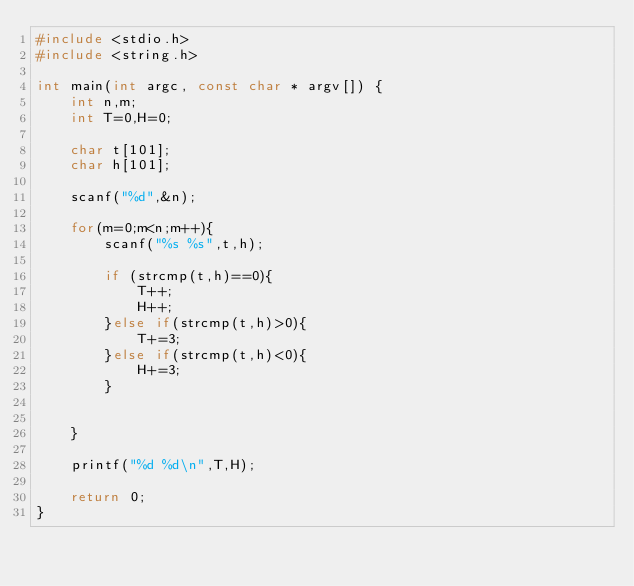<code> <loc_0><loc_0><loc_500><loc_500><_C_>#include <stdio.h>
#include <string.h>

int main(int argc, const char * argv[]) {
    int n,m;
    int T=0,H=0;
    
    char t[101];
    char h[101];
    
    scanf("%d",&n);
    
    for(m=0;m<n;m++){
        scanf("%s %s",t,h);
        
        if (strcmp(t,h)==0){
            T++;
            H++;
        }else if(strcmp(t,h)>0){
            T+=3;
        }else if(strcmp(t,h)<0){
            H+=3;
        }
        
        
    }
    
    printf("%d %d\n",T,H);
    
    return 0;
}
</code> 